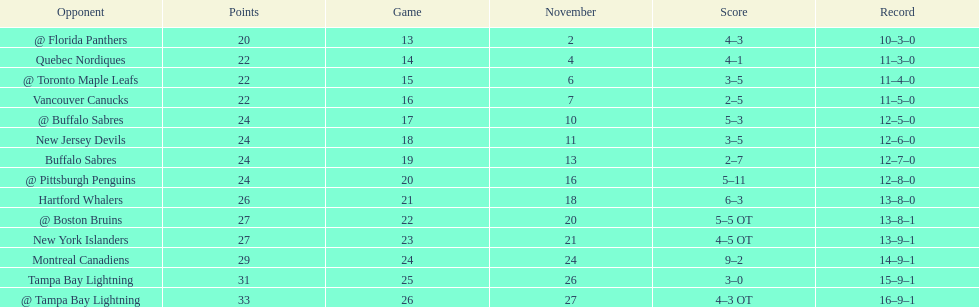Did the tampa bay lightning have the least amount of wins? Yes. 